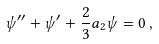Convert formula to latex. <formula><loc_0><loc_0><loc_500><loc_500>\psi ^ { \prime \prime } + \psi ^ { \prime } + \frac { 2 } { 3 } a _ { 2 } \psi = 0 \, ,</formula> 